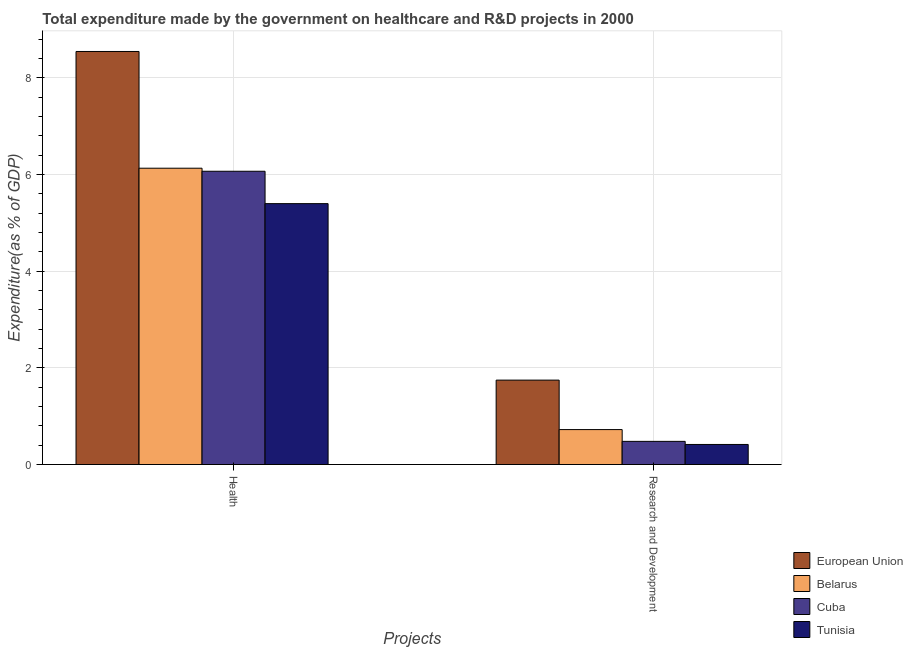How many groups of bars are there?
Ensure brevity in your answer.  2. Are the number of bars per tick equal to the number of legend labels?
Your answer should be very brief. Yes. Are the number of bars on each tick of the X-axis equal?
Give a very brief answer. Yes. What is the label of the 1st group of bars from the left?
Keep it short and to the point. Health. What is the expenditure in healthcare in Tunisia?
Make the answer very short. 5.4. Across all countries, what is the maximum expenditure in healthcare?
Make the answer very short. 8.54. Across all countries, what is the minimum expenditure in r&d?
Give a very brief answer. 0.41. In which country was the expenditure in healthcare maximum?
Your answer should be very brief. European Union. In which country was the expenditure in healthcare minimum?
Make the answer very short. Tunisia. What is the total expenditure in healthcare in the graph?
Offer a terse response. 26.13. What is the difference between the expenditure in healthcare in Belarus and that in European Union?
Provide a succinct answer. -2.41. What is the difference between the expenditure in r&d in Cuba and the expenditure in healthcare in Tunisia?
Offer a terse response. -4.92. What is the average expenditure in healthcare per country?
Ensure brevity in your answer.  6.53. What is the difference between the expenditure in healthcare and expenditure in r&d in European Union?
Offer a terse response. 6.8. What is the ratio of the expenditure in r&d in Tunisia to that in Cuba?
Provide a short and direct response. 0.87. In how many countries, is the expenditure in r&d greater than the average expenditure in r&d taken over all countries?
Offer a terse response. 1. What does the 2nd bar from the left in Health represents?
Provide a succinct answer. Belarus. Are all the bars in the graph horizontal?
Offer a very short reply. No. How many countries are there in the graph?
Give a very brief answer. 4. Are the values on the major ticks of Y-axis written in scientific E-notation?
Give a very brief answer. No. Does the graph contain grids?
Provide a succinct answer. Yes. Where does the legend appear in the graph?
Offer a very short reply. Bottom right. What is the title of the graph?
Your answer should be very brief. Total expenditure made by the government on healthcare and R&D projects in 2000. Does "Bhutan" appear as one of the legend labels in the graph?
Provide a succinct answer. No. What is the label or title of the X-axis?
Your response must be concise. Projects. What is the label or title of the Y-axis?
Ensure brevity in your answer.  Expenditure(as % of GDP). What is the Expenditure(as % of GDP) of European Union in Health?
Your answer should be compact. 8.54. What is the Expenditure(as % of GDP) in Belarus in Health?
Make the answer very short. 6.13. What is the Expenditure(as % of GDP) in Cuba in Health?
Your answer should be compact. 6.07. What is the Expenditure(as % of GDP) of Tunisia in Health?
Keep it short and to the point. 5.4. What is the Expenditure(as % of GDP) in European Union in Research and Development?
Keep it short and to the point. 1.75. What is the Expenditure(as % of GDP) of Belarus in Research and Development?
Provide a succinct answer. 0.72. What is the Expenditure(as % of GDP) in Cuba in Research and Development?
Give a very brief answer. 0.48. What is the Expenditure(as % of GDP) of Tunisia in Research and Development?
Offer a terse response. 0.41. Across all Projects, what is the maximum Expenditure(as % of GDP) in European Union?
Give a very brief answer. 8.54. Across all Projects, what is the maximum Expenditure(as % of GDP) of Belarus?
Offer a very short reply. 6.13. Across all Projects, what is the maximum Expenditure(as % of GDP) in Cuba?
Your answer should be compact. 6.07. Across all Projects, what is the maximum Expenditure(as % of GDP) in Tunisia?
Provide a succinct answer. 5.4. Across all Projects, what is the minimum Expenditure(as % of GDP) in European Union?
Offer a very short reply. 1.75. Across all Projects, what is the minimum Expenditure(as % of GDP) of Belarus?
Make the answer very short. 0.72. Across all Projects, what is the minimum Expenditure(as % of GDP) in Cuba?
Keep it short and to the point. 0.48. Across all Projects, what is the minimum Expenditure(as % of GDP) of Tunisia?
Your answer should be compact. 0.41. What is the total Expenditure(as % of GDP) in European Union in the graph?
Give a very brief answer. 10.29. What is the total Expenditure(as % of GDP) in Belarus in the graph?
Offer a very short reply. 6.85. What is the total Expenditure(as % of GDP) in Cuba in the graph?
Your response must be concise. 6.54. What is the total Expenditure(as % of GDP) of Tunisia in the graph?
Provide a succinct answer. 5.81. What is the difference between the Expenditure(as % of GDP) in European Union in Health and that in Research and Development?
Your answer should be very brief. 6.8. What is the difference between the Expenditure(as % of GDP) in Belarus in Health and that in Research and Development?
Your answer should be compact. 5.41. What is the difference between the Expenditure(as % of GDP) in Cuba in Health and that in Research and Development?
Provide a succinct answer. 5.59. What is the difference between the Expenditure(as % of GDP) in Tunisia in Health and that in Research and Development?
Keep it short and to the point. 4.98. What is the difference between the Expenditure(as % of GDP) in European Union in Health and the Expenditure(as % of GDP) in Belarus in Research and Development?
Make the answer very short. 7.82. What is the difference between the Expenditure(as % of GDP) of European Union in Health and the Expenditure(as % of GDP) of Cuba in Research and Development?
Offer a very short reply. 8.06. What is the difference between the Expenditure(as % of GDP) in European Union in Health and the Expenditure(as % of GDP) in Tunisia in Research and Development?
Your answer should be very brief. 8.13. What is the difference between the Expenditure(as % of GDP) of Belarus in Health and the Expenditure(as % of GDP) of Cuba in Research and Development?
Your response must be concise. 5.65. What is the difference between the Expenditure(as % of GDP) of Belarus in Health and the Expenditure(as % of GDP) of Tunisia in Research and Development?
Your answer should be very brief. 5.71. What is the difference between the Expenditure(as % of GDP) in Cuba in Health and the Expenditure(as % of GDP) in Tunisia in Research and Development?
Make the answer very short. 5.65. What is the average Expenditure(as % of GDP) in European Union per Projects?
Keep it short and to the point. 5.14. What is the average Expenditure(as % of GDP) in Belarus per Projects?
Your response must be concise. 3.43. What is the average Expenditure(as % of GDP) in Cuba per Projects?
Your response must be concise. 3.27. What is the average Expenditure(as % of GDP) in Tunisia per Projects?
Offer a very short reply. 2.91. What is the difference between the Expenditure(as % of GDP) in European Union and Expenditure(as % of GDP) in Belarus in Health?
Offer a very short reply. 2.41. What is the difference between the Expenditure(as % of GDP) in European Union and Expenditure(as % of GDP) in Cuba in Health?
Give a very brief answer. 2.48. What is the difference between the Expenditure(as % of GDP) in European Union and Expenditure(as % of GDP) in Tunisia in Health?
Your answer should be compact. 3.15. What is the difference between the Expenditure(as % of GDP) of Belarus and Expenditure(as % of GDP) of Cuba in Health?
Your answer should be compact. 0.06. What is the difference between the Expenditure(as % of GDP) in Belarus and Expenditure(as % of GDP) in Tunisia in Health?
Keep it short and to the point. 0.73. What is the difference between the Expenditure(as % of GDP) of Cuba and Expenditure(as % of GDP) of Tunisia in Health?
Ensure brevity in your answer.  0.67. What is the difference between the Expenditure(as % of GDP) of European Union and Expenditure(as % of GDP) of Belarus in Research and Development?
Make the answer very short. 1.02. What is the difference between the Expenditure(as % of GDP) in European Union and Expenditure(as % of GDP) in Cuba in Research and Development?
Make the answer very short. 1.27. What is the difference between the Expenditure(as % of GDP) in European Union and Expenditure(as % of GDP) in Tunisia in Research and Development?
Your response must be concise. 1.33. What is the difference between the Expenditure(as % of GDP) in Belarus and Expenditure(as % of GDP) in Cuba in Research and Development?
Offer a very short reply. 0.24. What is the difference between the Expenditure(as % of GDP) in Belarus and Expenditure(as % of GDP) in Tunisia in Research and Development?
Give a very brief answer. 0.31. What is the difference between the Expenditure(as % of GDP) in Cuba and Expenditure(as % of GDP) in Tunisia in Research and Development?
Your answer should be very brief. 0.06. What is the ratio of the Expenditure(as % of GDP) in European Union in Health to that in Research and Development?
Give a very brief answer. 4.89. What is the ratio of the Expenditure(as % of GDP) of Belarus in Health to that in Research and Development?
Your answer should be compact. 8.49. What is the ratio of the Expenditure(as % of GDP) in Cuba in Health to that in Research and Development?
Make the answer very short. 12.67. What is the ratio of the Expenditure(as % of GDP) in Tunisia in Health to that in Research and Development?
Keep it short and to the point. 13.02. What is the difference between the highest and the second highest Expenditure(as % of GDP) of European Union?
Your answer should be compact. 6.8. What is the difference between the highest and the second highest Expenditure(as % of GDP) of Belarus?
Offer a very short reply. 5.41. What is the difference between the highest and the second highest Expenditure(as % of GDP) of Cuba?
Ensure brevity in your answer.  5.59. What is the difference between the highest and the second highest Expenditure(as % of GDP) in Tunisia?
Offer a terse response. 4.98. What is the difference between the highest and the lowest Expenditure(as % of GDP) of European Union?
Keep it short and to the point. 6.8. What is the difference between the highest and the lowest Expenditure(as % of GDP) of Belarus?
Provide a succinct answer. 5.41. What is the difference between the highest and the lowest Expenditure(as % of GDP) in Cuba?
Give a very brief answer. 5.59. What is the difference between the highest and the lowest Expenditure(as % of GDP) of Tunisia?
Make the answer very short. 4.98. 